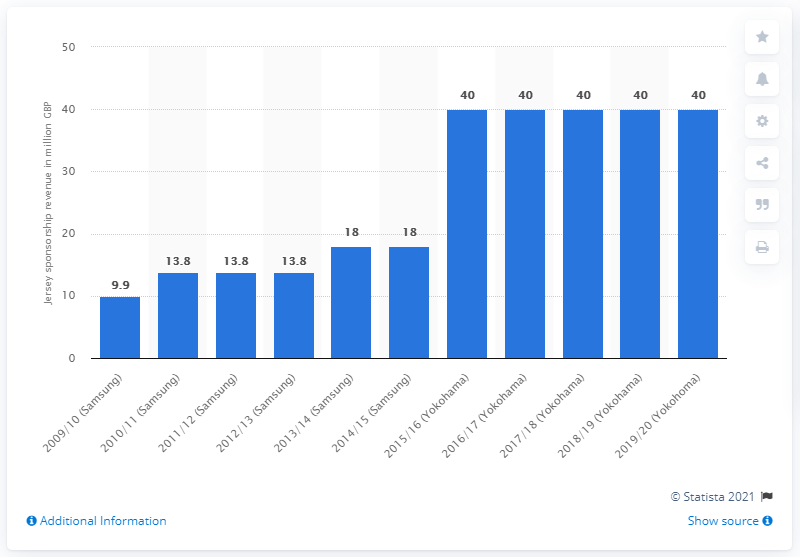Give some essential details in this illustration. In the 2019/2020 season, Chelsea received a total of 40 million GBP from Yokohama. 